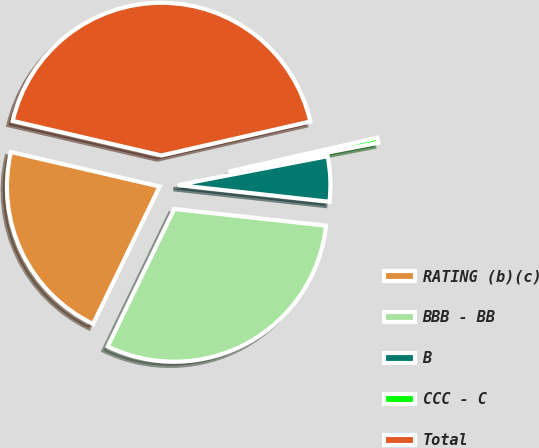Convert chart to OTSL. <chart><loc_0><loc_0><loc_500><loc_500><pie_chart><fcel>RATING (b)(c)<fcel>BBB - BB<fcel>B<fcel>CCC - C<fcel>Total<nl><fcel>21.45%<fcel>30.43%<fcel>4.77%<fcel>0.54%<fcel>42.8%<nl></chart> 